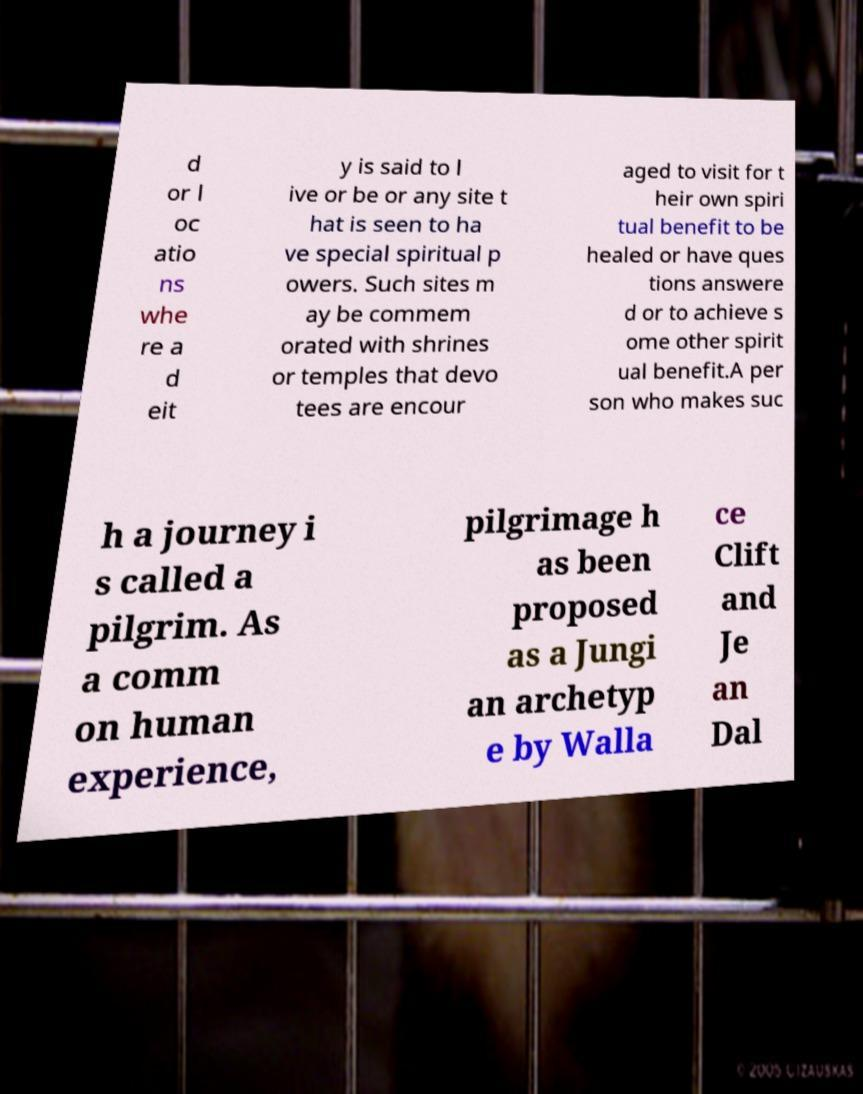Please read and relay the text visible in this image. What does it say? d or l oc atio ns whe re a d eit y is said to l ive or be or any site t hat is seen to ha ve special spiritual p owers. Such sites m ay be commem orated with shrines or temples that devo tees are encour aged to visit for t heir own spiri tual benefit to be healed or have ques tions answere d or to achieve s ome other spirit ual benefit.A per son who makes suc h a journey i s called a pilgrim. As a comm on human experience, pilgrimage h as been proposed as a Jungi an archetyp e by Walla ce Clift and Je an Dal 